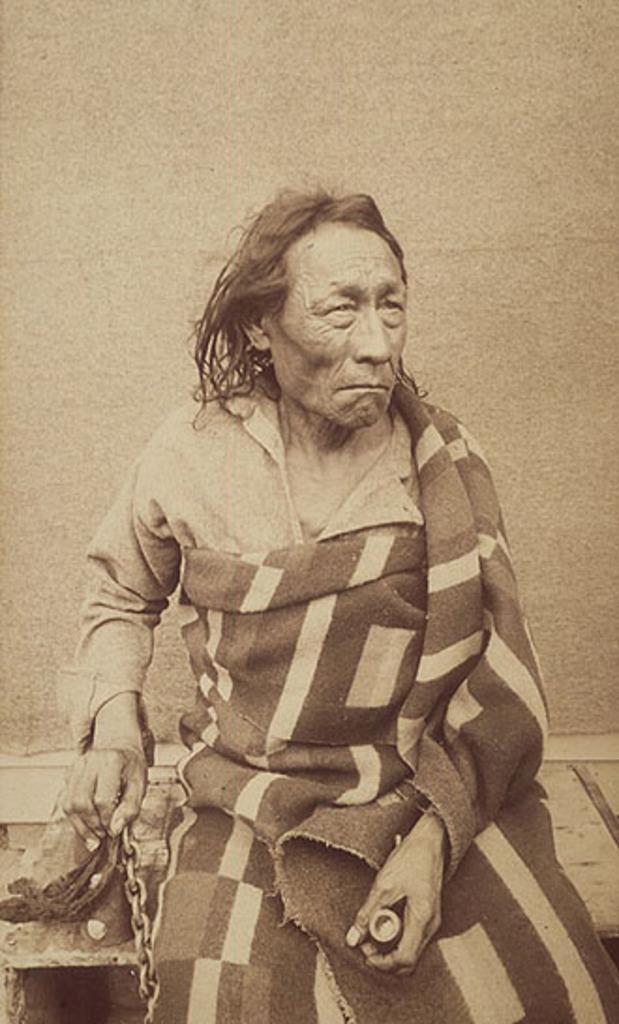How would you summarize this image in a sentence or two? In this image there is a person sitting on the wooden bench and holding a chain. In the background there is a wall. 